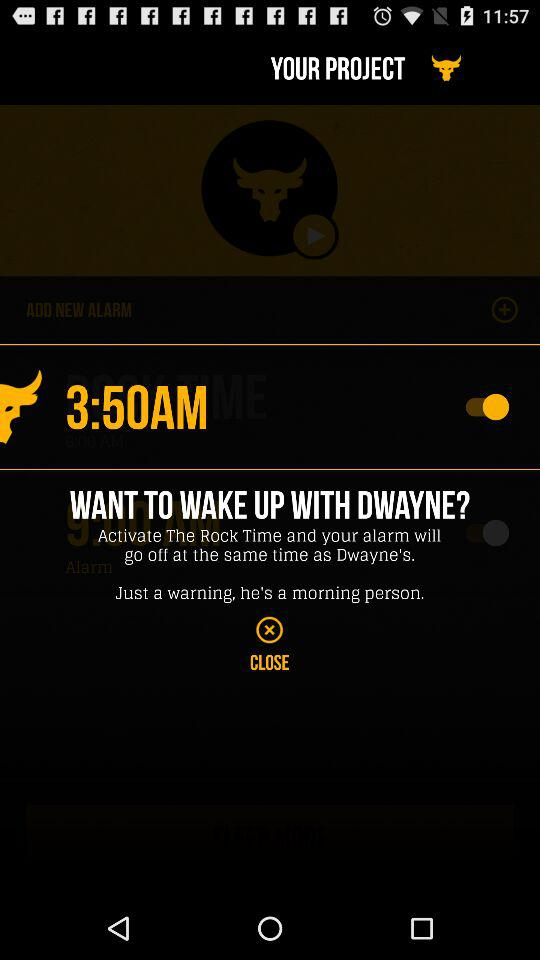What is the status of "3:50AM"? The status is "on". 